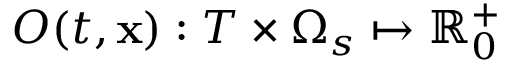<formula> <loc_0><loc_0><loc_500><loc_500>O ( t , x ) \colon T \times \Omega _ { s } \mapsto \mathbb { R } _ { 0 } ^ { + }</formula> 